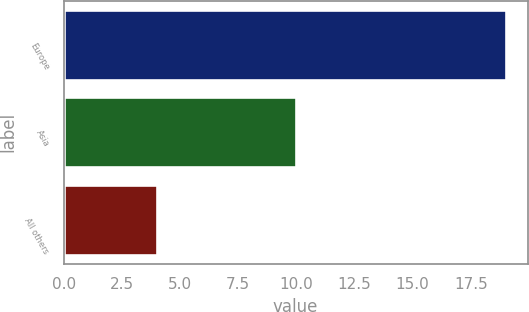<chart> <loc_0><loc_0><loc_500><loc_500><bar_chart><fcel>Europe<fcel>Asia<fcel>All others<nl><fcel>19<fcel>10<fcel>4<nl></chart> 